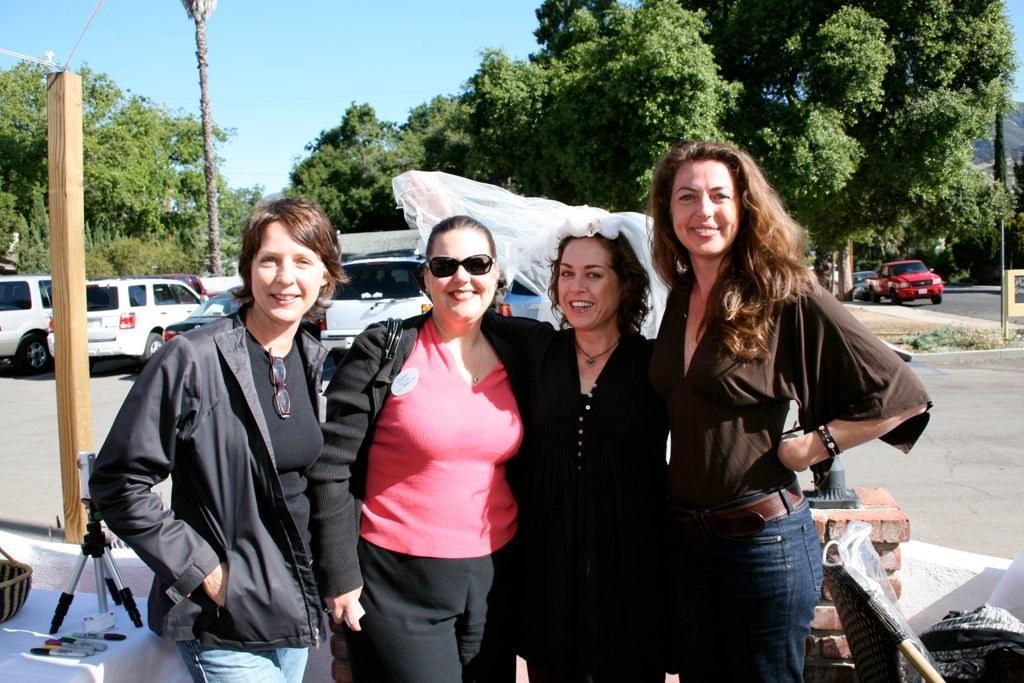Describe this image in one or two sentences. In this picture we can see four people and they are smiling and in the background we can see vehicles, trees, sky and some objects. 